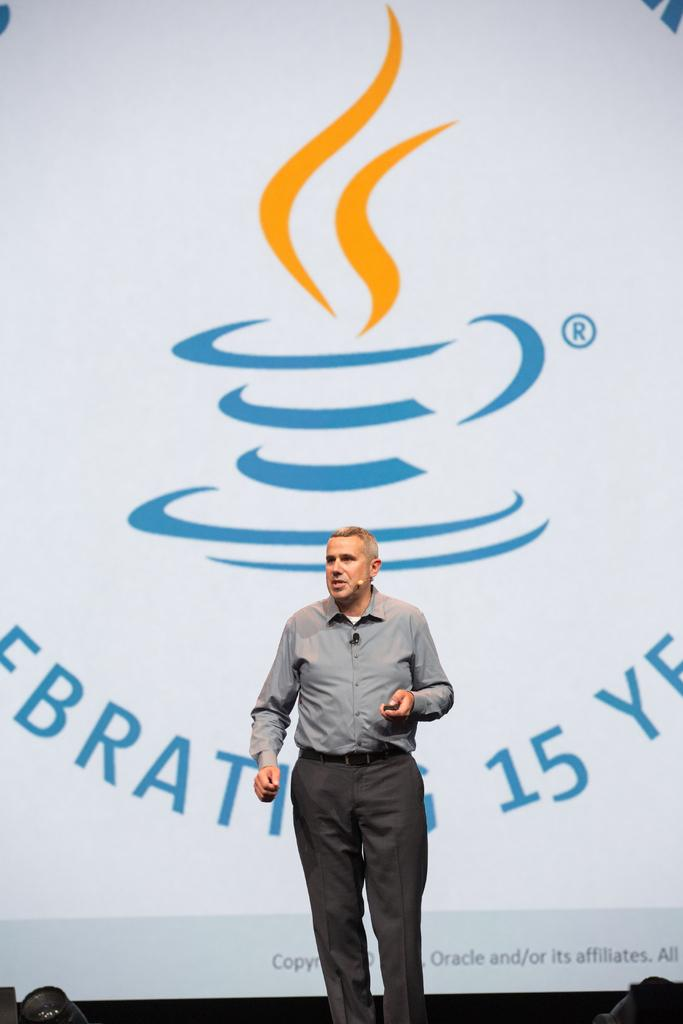What is the main subject of the image? The main subject of the image is a man. What is the man doing in the image? The man is standing and appears to be talking. What is the man wearing in the image? The man is wearing a shirt and trousers. What can be seen in the background of the image? There is a banner in the background of the image. What design is on the banner? The banner has a cup and saucer design on it. Are there any additional elements on the banner? Yes, there are some smokes on the banner. How many passengers are visible on the banner? There are no passengers visible on the banner; it features a cup and saucer design with some smokes. What type of hook is used to hang the basket on the banner? There is no basket or hook present on the banner; it only has a cup and saucer design with smokes. 